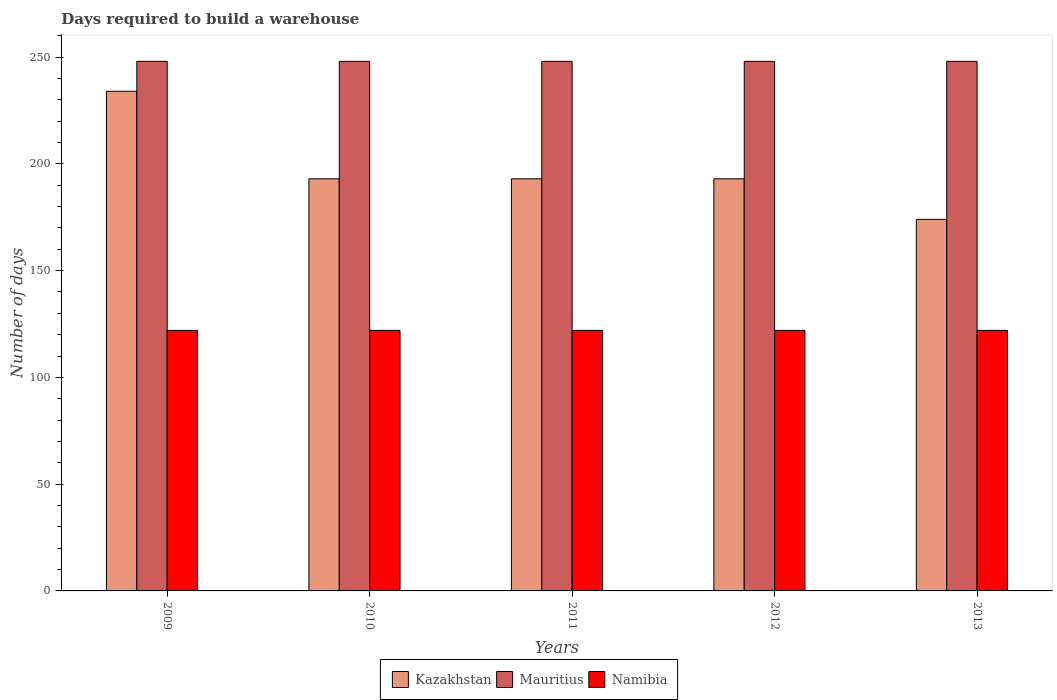How many different coloured bars are there?
Provide a succinct answer. 3. Are the number of bars on each tick of the X-axis equal?
Offer a very short reply. Yes. How many bars are there on the 5th tick from the right?
Offer a terse response. 3. In how many cases, is the number of bars for a given year not equal to the number of legend labels?
Ensure brevity in your answer.  0. What is the days required to build a warehouse in in Kazakhstan in 2011?
Make the answer very short. 193. Across all years, what is the maximum days required to build a warehouse in in Mauritius?
Make the answer very short. 248. Across all years, what is the minimum days required to build a warehouse in in Mauritius?
Make the answer very short. 248. What is the total days required to build a warehouse in in Kazakhstan in the graph?
Your answer should be very brief. 987. What is the difference between the days required to build a warehouse in in Mauritius in 2011 and the days required to build a warehouse in in Namibia in 2010?
Make the answer very short. 126. What is the average days required to build a warehouse in in Mauritius per year?
Make the answer very short. 248. In the year 2012, what is the difference between the days required to build a warehouse in in Kazakhstan and days required to build a warehouse in in Namibia?
Offer a terse response. 71. What is the ratio of the days required to build a warehouse in in Kazakhstan in 2009 to that in 2011?
Offer a terse response. 1.21. Is the days required to build a warehouse in in Namibia in 2010 less than that in 2011?
Your answer should be compact. No. Is the difference between the days required to build a warehouse in in Kazakhstan in 2010 and 2012 greater than the difference between the days required to build a warehouse in in Namibia in 2010 and 2012?
Provide a succinct answer. No. What is the difference between the highest and the second highest days required to build a warehouse in in Kazakhstan?
Offer a very short reply. 41. What is the difference between the highest and the lowest days required to build a warehouse in in Mauritius?
Keep it short and to the point. 0. What does the 2nd bar from the left in 2011 represents?
Your answer should be compact. Mauritius. What does the 3rd bar from the right in 2011 represents?
Provide a short and direct response. Kazakhstan. Is it the case that in every year, the sum of the days required to build a warehouse in in Mauritius and days required to build a warehouse in in Namibia is greater than the days required to build a warehouse in in Kazakhstan?
Your response must be concise. Yes. How many bars are there?
Offer a very short reply. 15. Are all the bars in the graph horizontal?
Provide a short and direct response. No. Are the values on the major ticks of Y-axis written in scientific E-notation?
Your answer should be compact. No. Does the graph contain any zero values?
Your answer should be very brief. No. How many legend labels are there?
Give a very brief answer. 3. What is the title of the graph?
Offer a terse response. Days required to build a warehouse. What is the label or title of the X-axis?
Your answer should be very brief. Years. What is the label or title of the Y-axis?
Make the answer very short. Number of days. What is the Number of days in Kazakhstan in 2009?
Provide a short and direct response. 234. What is the Number of days in Mauritius in 2009?
Your answer should be very brief. 248. What is the Number of days of Namibia in 2009?
Your answer should be very brief. 122. What is the Number of days in Kazakhstan in 2010?
Offer a terse response. 193. What is the Number of days of Mauritius in 2010?
Provide a succinct answer. 248. What is the Number of days in Namibia in 2010?
Offer a terse response. 122. What is the Number of days in Kazakhstan in 2011?
Offer a terse response. 193. What is the Number of days in Mauritius in 2011?
Your response must be concise. 248. What is the Number of days of Namibia in 2011?
Provide a succinct answer. 122. What is the Number of days of Kazakhstan in 2012?
Ensure brevity in your answer.  193. What is the Number of days of Mauritius in 2012?
Make the answer very short. 248. What is the Number of days in Namibia in 2012?
Keep it short and to the point. 122. What is the Number of days in Kazakhstan in 2013?
Offer a terse response. 174. What is the Number of days in Mauritius in 2013?
Give a very brief answer. 248. What is the Number of days in Namibia in 2013?
Keep it short and to the point. 122. Across all years, what is the maximum Number of days of Kazakhstan?
Your response must be concise. 234. Across all years, what is the maximum Number of days in Mauritius?
Make the answer very short. 248. Across all years, what is the maximum Number of days in Namibia?
Your response must be concise. 122. Across all years, what is the minimum Number of days in Kazakhstan?
Provide a succinct answer. 174. Across all years, what is the minimum Number of days of Mauritius?
Keep it short and to the point. 248. Across all years, what is the minimum Number of days of Namibia?
Your response must be concise. 122. What is the total Number of days in Kazakhstan in the graph?
Keep it short and to the point. 987. What is the total Number of days of Mauritius in the graph?
Your answer should be compact. 1240. What is the total Number of days in Namibia in the graph?
Your response must be concise. 610. What is the difference between the Number of days in Mauritius in 2009 and that in 2010?
Your response must be concise. 0. What is the difference between the Number of days of Mauritius in 2009 and that in 2012?
Ensure brevity in your answer.  0. What is the difference between the Number of days in Namibia in 2009 and that in 2012?
Give a very brief answer. 0. What is the difference between the Number of days in Kazakhstan in 2009 and that in 2013?
Offer a very short reply. 60. What is the difference between the Number of days in Mauritius in 2009 and that in 2013?
Your answer should be compact. 0. What is the difference between the Number of days in Namibia in 2009 and that in 2013?
Make the answer very short. 0. What is the difference between the Number of days of Kazakhstan in 2010 and that in 2011?
Your answer should be compact. 0. What is the difference between the Number of days in Mauritius in 2010 and that in 2011?
Ensure brevity in your answer.  0. What is the difference between the Number of days in Namibia in 2010 and that in 2011?
Provide a succinct answer. 0. What is the difference between the Number of days in Kazakhstan in 2010 and that in 2012?
Provide a short and direct response. 0. What is the difference between the Number of days of Mauritius in 2010 and that in 2012?
Make the answer very short. 0. What is the difference between the Number of days of Namibia in 2010 and that in 2012?
Your answer should be very brief. 0. What is the difference between the Number of days of Mauritius in 2011 and that in 2012?
Your answer should be very brief. 0. What is the difference between the Number of days of Namibia in 2011 and that in 2012?
Your answer should be very brief. 0. What is the difference between the Number of days in Kazakhstan in 2012 and that in 2013?
Provide a short and direct response. 19. What is the difference between the Number of days in Kazakhstan in 2009 and the Number of days in Mauritius in 2010?
Offer a terse response. -14. What is the difference between the Number of days in Kazakhstan in 2009 and the Number of days in Namibia in 2010?
Give a very brief answer. 112. What is the difference between the Number of days of Mauritius in 2009 and the Number of days of Namibia in 2010?
Ensure brevity in your answer.  126. What is the difference between the Number of days of Kazakhstan in 2009 and the Number of days of Namibia in 2011?
Keep it short and to the point. 112. What is the difference between the Number of days in Mauritius in 2009 and the Number of days in Namibia in 2011?
Make the answer very short. 126. What is the difference between the Number of days in Kazakhstan in 2009 and the Number of days in Mauritius in 2012?
Make the answer very short. -14. What is the difference between the Number of days in Kazakhstan in 2009 and the Number of days in Namibia in 2012?
Your response must be concise. 112. What is the difference between the Number of days of Mauritius in 2009 and the Number of days of Namibia in 2012?
Offer a very short reply. 126. What is the difference between the Number of days in Kazakhstan in 2009 and the Number of days in Namibia in 2013?
Give a very brief answer. 112. What is the difference between the Number of days of Mauritius in 2009 and the Number of days of Namibia in 2013?
Keep it short and to the point. 126. What is the difference between the Number of days of Kazakhstan in 2010 and the Number of days of Mauritius in 2011?
Your answer should be very brief. -55. What is the difference between the Number of days of Kazakhstan in 2010 and the Number of days of Namibia in 2011?
Offer a very short reply. 71. What is the difference between the Number of days of Mauritius in 2010 and the Number of days of Namibia in 2011?
Keep it short and to the point. 126. What is the difference between the Number of days of Kazakhstan in 2010 and the Number of days of Mauritius in 2012?
Offer a terse response. -55. What is the difference between the Number of days in Kazakhstan in 2010 and the Number of days in Namibia in 2012?
Offer a very short reply. 71. What is the difference between the Number of days in Mauritius in 2010 and the Number of days in Namibia in 2012?
Provide a succinct answer. 126. What is the difference between the Number of days in Kazakhstan in 2010 and the Number of days in Mauritius in 2013?
Make the answer very short. -55. What is the difference between the Number of days in Kazakhstan in 2010 and the Number of days in Namibia in 2013?
Make the answer very short. 71. What is the difference between the Number of days of Mauritius in 2010 and the Number of days of Namibia in 2013?
Give a very brief answer. 126. What is the difference between the Number of days of Kazakhstan in 2011 and the Number of days of Mauritius in 2012?
Offer a terse response. -55. What is the difference between the Number of days in Mauritius in 2011 and the Number of days in Namibia in 2012?
Offer a very short reply. 126. What is the difference between the Number of days of Kazakhstan in 2011 and the Number of days of Mauritius in 2013?
Ensure brevity in your answer.  -55. What is the difference between the Number of days in Mauritius in 2011 and the Number of days in Namibia in 2013?
Your response must be concise. 126. What is the difference between the Number of days in Kazakhstan in 2012 and the Number of days in Mauritius in 2013?
Make the answer very short. -55. What is the difference between the Number of days of Kazakhstan in 2012 and the Number of days of Namibia in 2013?
Keep it short and to the point. 71. What is the difference between the Number of days of Mauritius in 2012 and the Number of days of Namibia in 2013?
Your response must be concise. 126. What is the average Number of days in Kazakhstan per year?
Make the answer very short. 197.4. What is the average Number of days in Mauritius per year?
Offer a very short reply. 248. What is the average Number of days of Namibia per year?
Your response must be concise. 122. In the year 2009, what is the difference between the Number of days in Kazakhstan and Number of days in Mauritius?
Keep it short and to the point. -14. In the year 2009, what is the difference between the Number of days of Kazakhstan and Number of days of Namibia?
Give a very brief answer. 112. In the year 2009, what is the difference between the Number of days in Mauritius and Number of days in Namibia?
Ensure brevity in your answer.  126. In the year 2010, what is the difference between the Number of days in Kazakhstan and Number of days in Mauritius?
Your answer should be compact. -55. In the year 2010, what is the difference between the Number of days in Mauritius and Number of days in Namibia?
Give a very brief answer. 126. In the year 2011, what is the difference between the Number of days of Kazakhstan and Number of days of Mauritius?
Ensure brevity in your answer.  -55. In the year 2011, what is the difference between the Number of days in Mauritius and Number of days in Namibia?
Offer a terse response. 126. In the year 2012, what is the difference between the Number of days of Kazakhstan and Number of days of Mauritius?
Give a very brief answer. -55. In the year 2012, what is the difference between the Number of days in Mauritius and Number of days in Namibia?
Your answer should be compact. 126. In the year 2013, what is the difference between the Number of days of Kazakhstan and Number of days of Mauritius?
Offer a very short reply. -74. In the year 2013, what is the difference between the Number of days in Kazakhstan and Number of days in Namibia?
Ensure brevity in your answer.  52. In the year 2013, what is the difference between the Number of days in Mauritius and Number of days in Namibia?
Provide a short and direct response. 126. What is the ratio of the Number of days in Kazakhstan in 2009 to that in 2010?
Provide a short and direct response. 1.21. What is the ratio of the Number of days in Namibia in 2009 to that in 2010?
Provide a short and direct response. 1. What is the ratio of the Number of days in Kazakhstan in 2009 to that in 2011?
Give a very brief answer. 1.21. What is the ratio of the Number of days in Mauritius in 2009 to that in 2011?
Ensure brevity in your answer.  1. What is the ratio of the Number of days of Namibia in 2009 to that in 2011?
Make the answer very short. 1. What is the ratio of the Number of days in Kazakhstan in 2009 to that in 2012?
Provide a short and direct response. 1.21. What is the ratio of the Number of days of Namibia in 2009 to that in 2012?
Keep it short and to the point. 1. What is the ratio of the Number of days in Kazakhstan in 2009 to that in 2013?
Provide a short and direct response. 1.34. What is the ratio of the Number of days in Mauritius in 2009 to that in 2013?
Your answer should be compact. 1. What is the ratio of the Number of days of Namibia in 2009 to that in 2013?
Keep it short and to the point. 1. What is the ratio of the Number of days in Mauritius in 2010 to that in 2011?
Your answer should be very brief. 1. What is the ratio of the Number of days in Mauritius in 2010 to that in 2012?
Your answer should be very brief. 1. What is the ratio of the Number of days in Kazakhstan in 2010 to that in 2013?
Keep it short and to the point. 1.11. What is the ratio of the Number of days of Mauritius in 2011 to that in 2012?
Offer a very short reply. 1. What is the ratio of the Number of days in Kazakhstan in 2011 to that in 2013?
Ensure brevity in your answer.  1.11. What is the ratio of the Number of days of Mauritius in 2011 to that in 2013?
Your answer should be very brief. 1. What is the ratio of the Number of days in Namibia in 2011 to that in 2013?
Ensure brevity in your answer.  1. What is the ratio of the Number of days of Kazakhstan in 2012 to that in 2013?
Provide a succinct answer. 1.11. What is the ratio of the Number of days of Mauritius in 2012 to that in 2013?
Provide a succinct answer. 1. What is the difference between the highest and the second highest Number of days of Kazakhstan?
Your response must be concise. 41. 